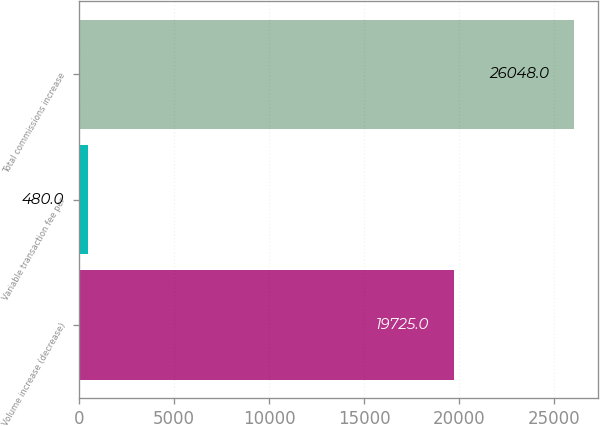<chart> <loc_0><loc_0><loc_500><loc_500><bar_chart><fcel>Volume increase (decrease)<fcel>Variable transaction fee per<fcel>Total commissions increase<nl><fcel>19725<fcel>480<fcel>26048<nl></chart> 